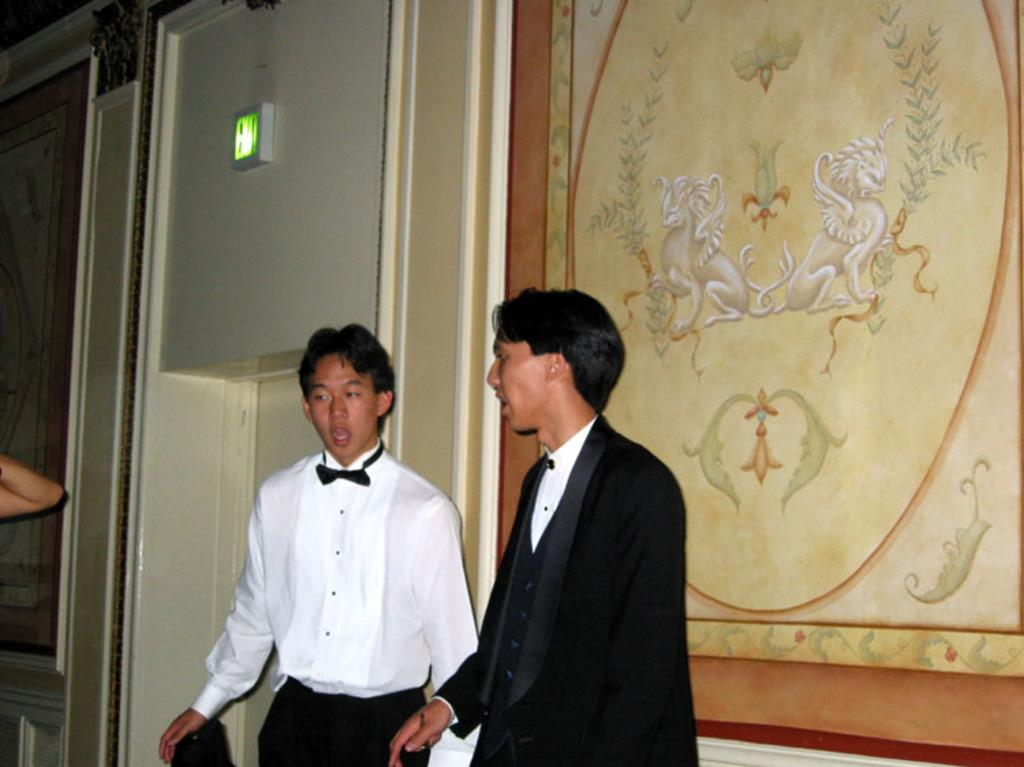How many people are in the image? There are two persons in the image. What can be seen in the background of the image? There is a painting on the wall and other objects present in the background of the image. What type of bun is being used as a prop in the image? There is no bun present in the image. What type of voyage are the two persons embarking on in the image? There is no indication of a voyage in the image; it simply shows two persons and a painting on the wall. 